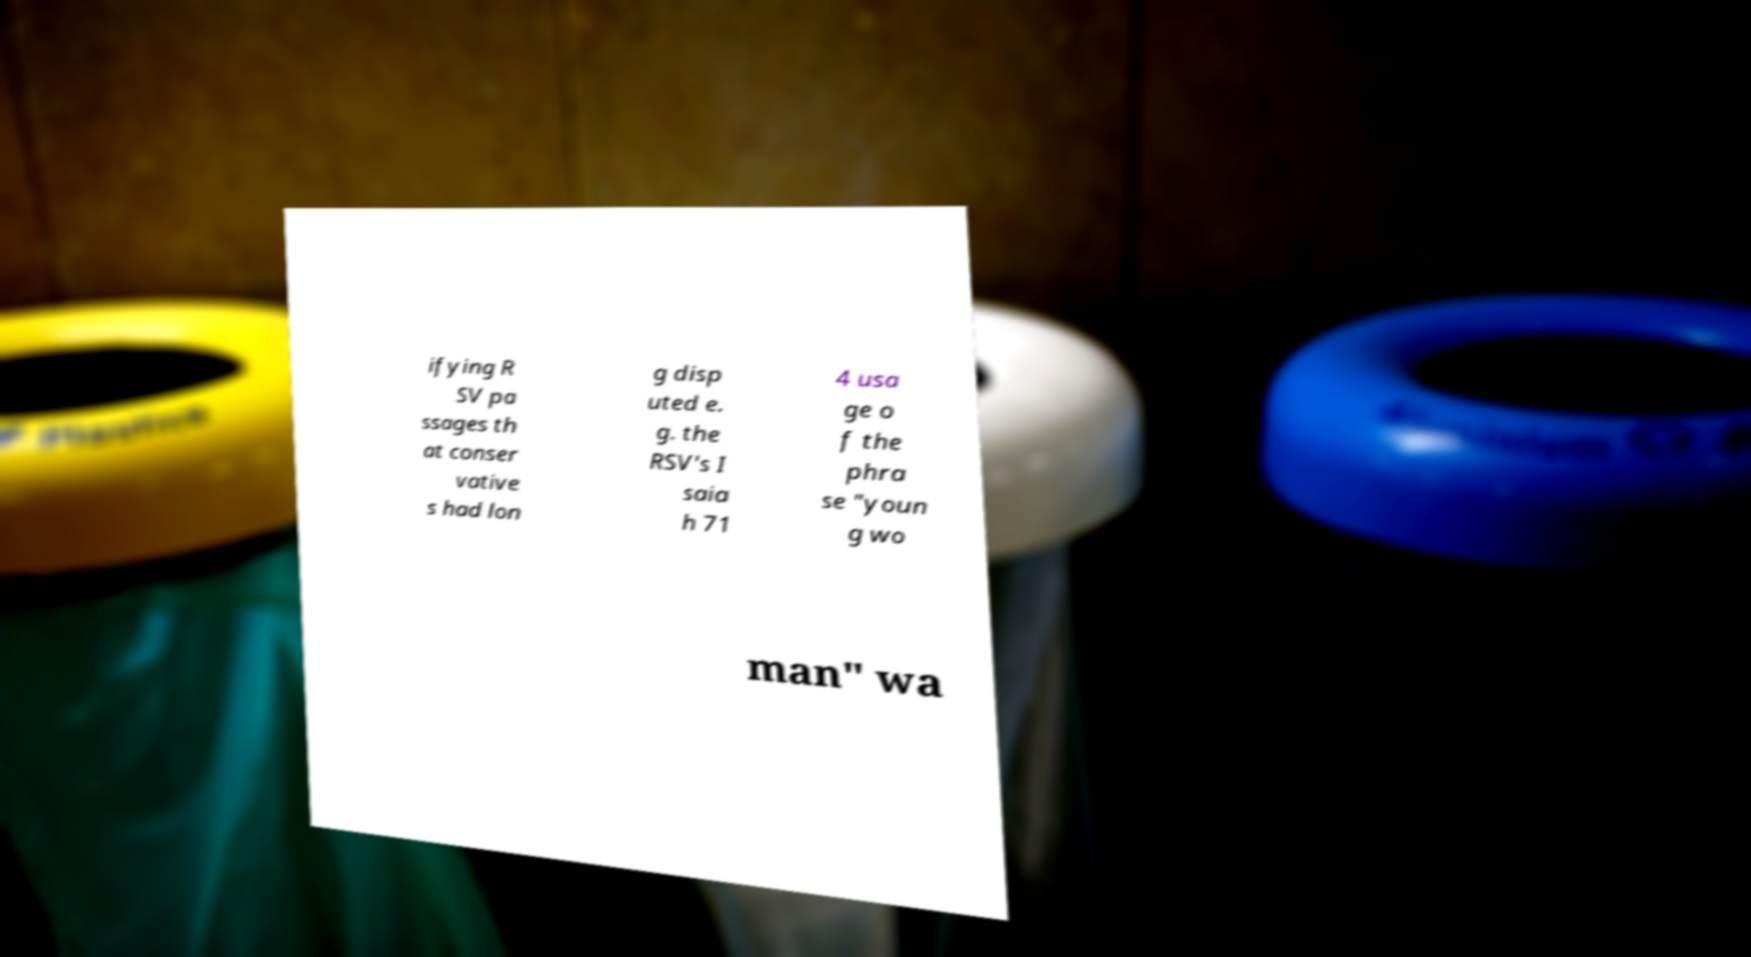I need the written content from this picture converted into text. Can you do that? ifying R SV pa ssages th at conser vative s had lon g disp uted e. g. the RSV's I saia h 71 4 usa ge o f the phra se "youn g wo man" wa 